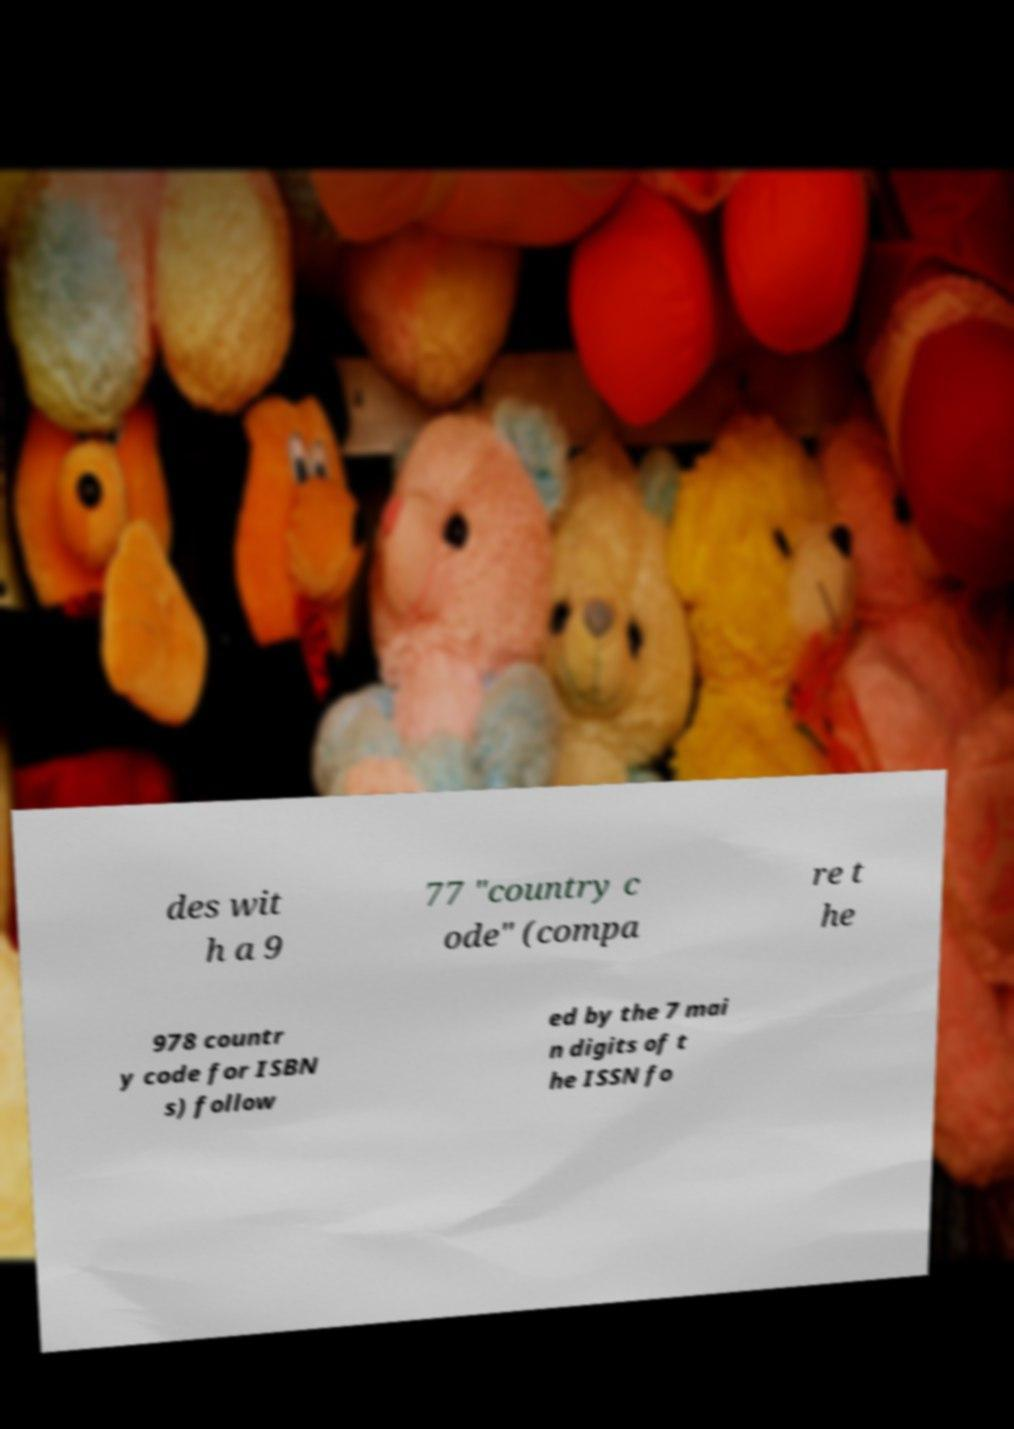Could you extract and type out the text from this image? des wit h a 9 77 "country c ode" (compa re t he 978 countr y code for ISBN s) follow ed by the 7 mai n digits of t he ISSN fo 